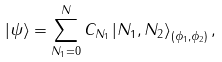Convert formula to latex. <formula><loc_0><loc_0><loc_500><loc_500>\left | \psi \right \rangle = \sum _ { N _ { 1 } = 0 } ^ { N } C _ { N _ { 1 } } \left | N _ { 1 } , N _ { 2 } \right \rangle _ { ( \phi _ { 1 } , \phi _ { 2 } ) } ,</formula> 